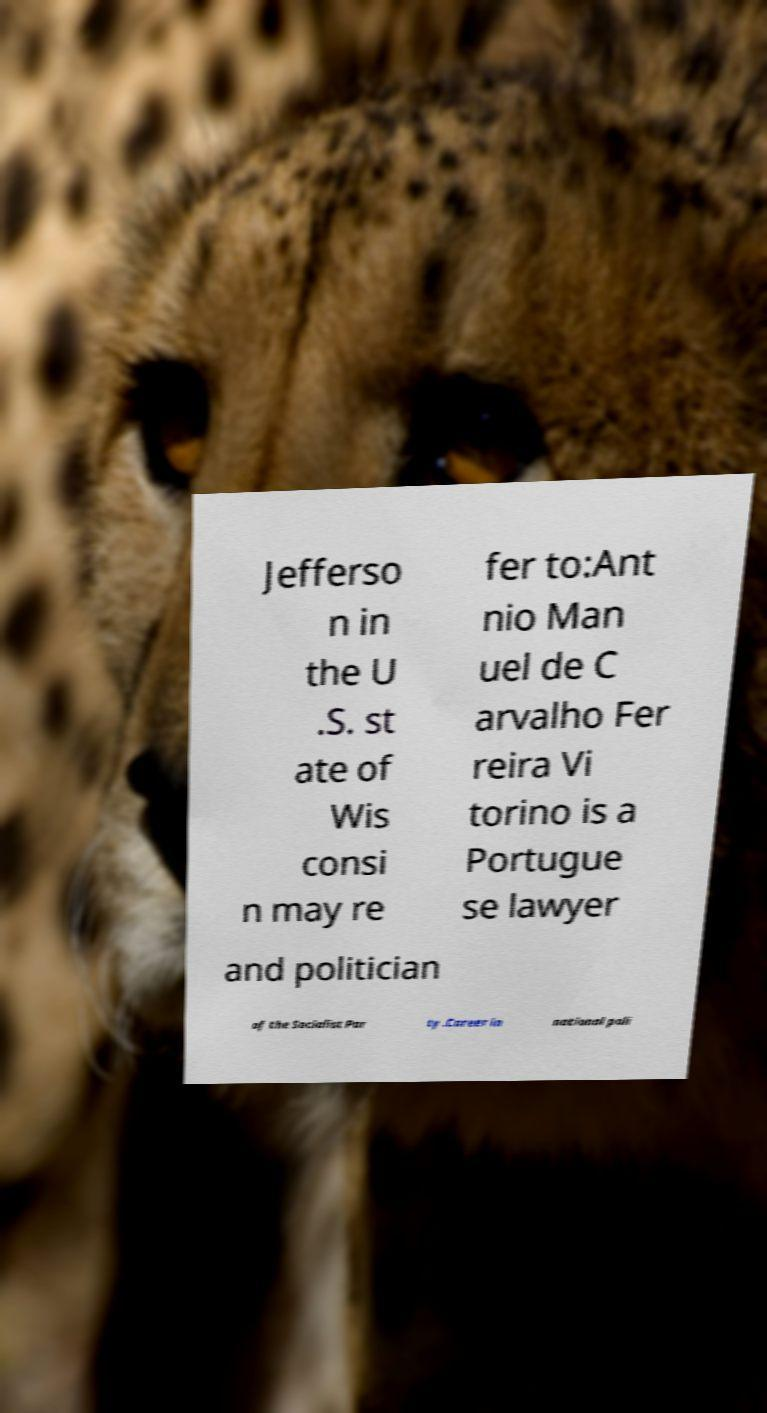What messages or text are displayed in this image? I need them in a readable, typed format. Jefferso n in the U .S. st ate of Wis consi n may re fer to:Ant nio Man uel de C arvalho Fer reira Vi torino is a Portugue se lawyer and politician of the Socialist Par ty .Career in national poli 